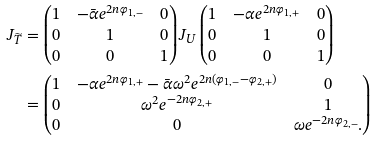<formula> <loc_0><loc_0><loc_500><loc_500>J _ { \widetilde { T } } & = \begin{pmatrix} 1 & - \bar { \alpha } e ^ { 2 n \varphi _ { 1 , - } } & 0 \\ 0 & 1 & 0 \\ 0 & 0 & 1 \end{pmatrix} J _ { U } \begin{pmatrix} 1 & - \alpha e ^ { 2 n \varphi _ { 1 , + } } & 0 \\ 0 & 1 & 0 \\ 0 & 0 & 1 \end{pmatrix} \\ & = \begin{pmatrix} 1 & - \alpha e ^ { 2 n \varphi _ { 1 , + } } - \bar { \alpha } \omega ^ { 2 } e ^ { 2 n ( \varphi _ { 1 , - } - \varphi _ { 2 , + } ) } & 0 \\ 0 & \omega ^ { 2 } e ^ { - 2 n \varphi _ { 2 , + } } & 1 \\ 0 & 0 & \omega e ^ { - 2 n \varphi _ { 2 , - } } . \end{pmatrix}</formula> 